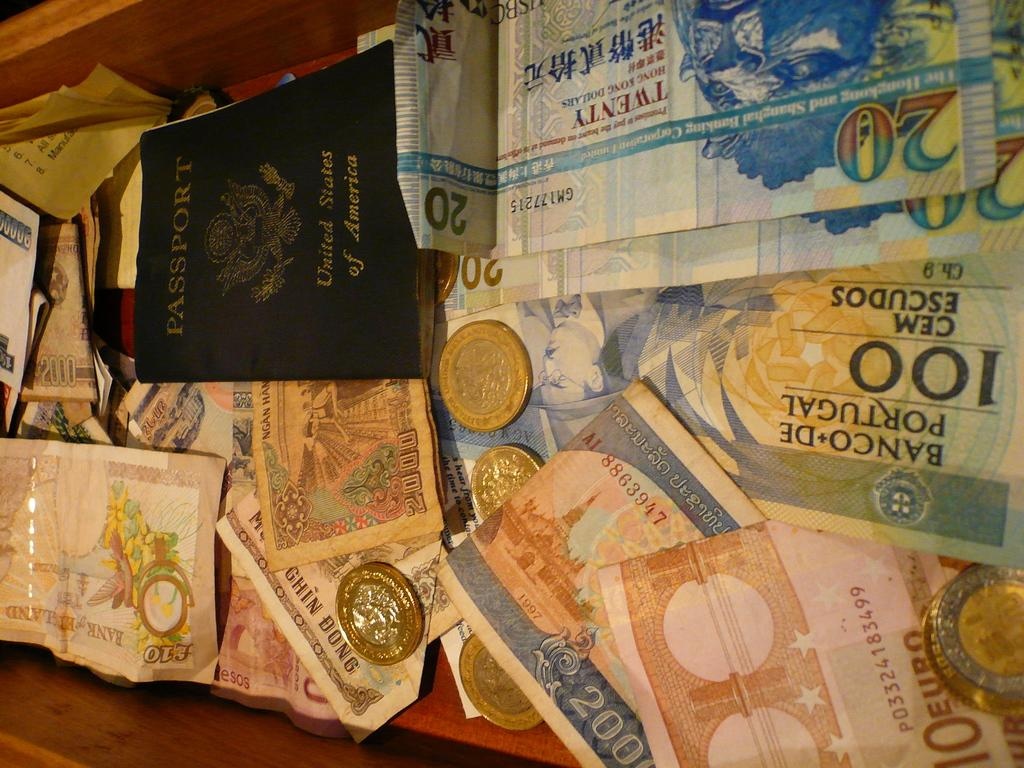Provide a one-sentence caption for the provided image. Portuguese bank notes of 10, 20 and 100 denomination. 